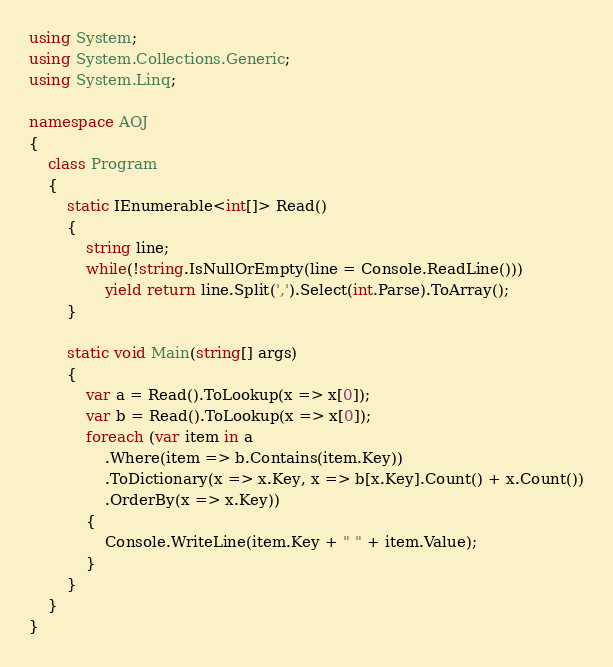<code> <loc_0><loc_0><loc_500><loc_500><_C#_>using System;
using System.Collections.Generic;
using System.Linq;

namespace AOJ
{
    class Program
    {
        static IEnumerable<int[]> Read()
        {
            string line;
            while(!string.IsNullOrEmpty(line = Console.ReadLine()))
                yield return line.Split(',').Select(int.Parse).ToArray();
        }

        static void Main(string[] args)
        {
            var a = Read().ToLookup(x => x[0]);
            var b = Read().ToLookup(x => x[0]);
            foreach (var item in a
                .Where(item => b.Contains(item.Key))
                .ToDictionary(x => x.Key, x => b[x.Key].Count() + x.Count())
                .OrderBy(x => x.Key))
            {
                Console.WriteLine(item.Key + " " + item.Value);
            }
        }
    }
}</code> 